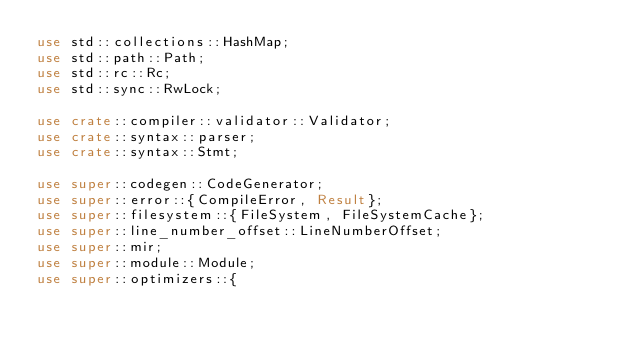Convert code to text. <code><loc_0><loc_0><loc_500><loc_500><_Rust_>use std::collections::HashMap;
use std::path::Path;
use std::rc::Rc;
use std::sync::RwLock;

use crate::compiler::validator::Validator;
use crate::syntax::parser;
use crate::syntax::Stmt;

use super::codegen::CodeGenerator;
use super::error::{CompileError, Result};
use super::filesystem::{FileSystem, FileSystemCache};
use super::line_number_offset::LineNumberOffset;
use super::mir;
use super::module::Module;
use super::optimizers::{</code> 